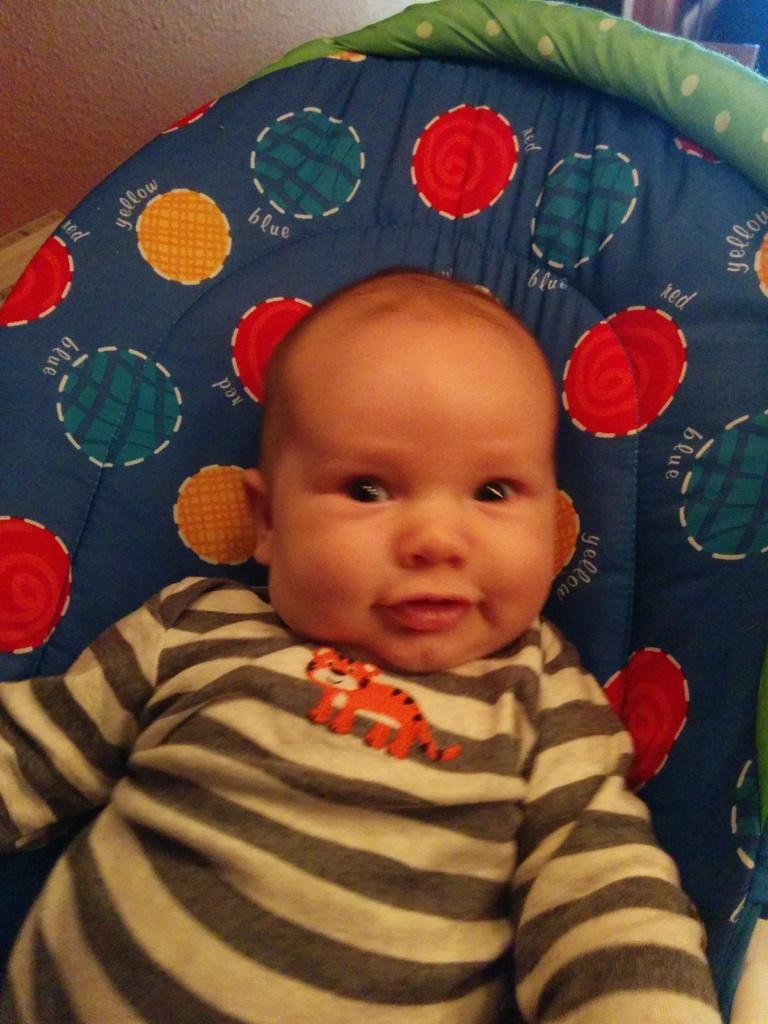In one or two sentences, can you explain what this image depicts? In this picture there is a kid with grey t-shirt is sitting in the baby traveler. In the top left there is a wall. 